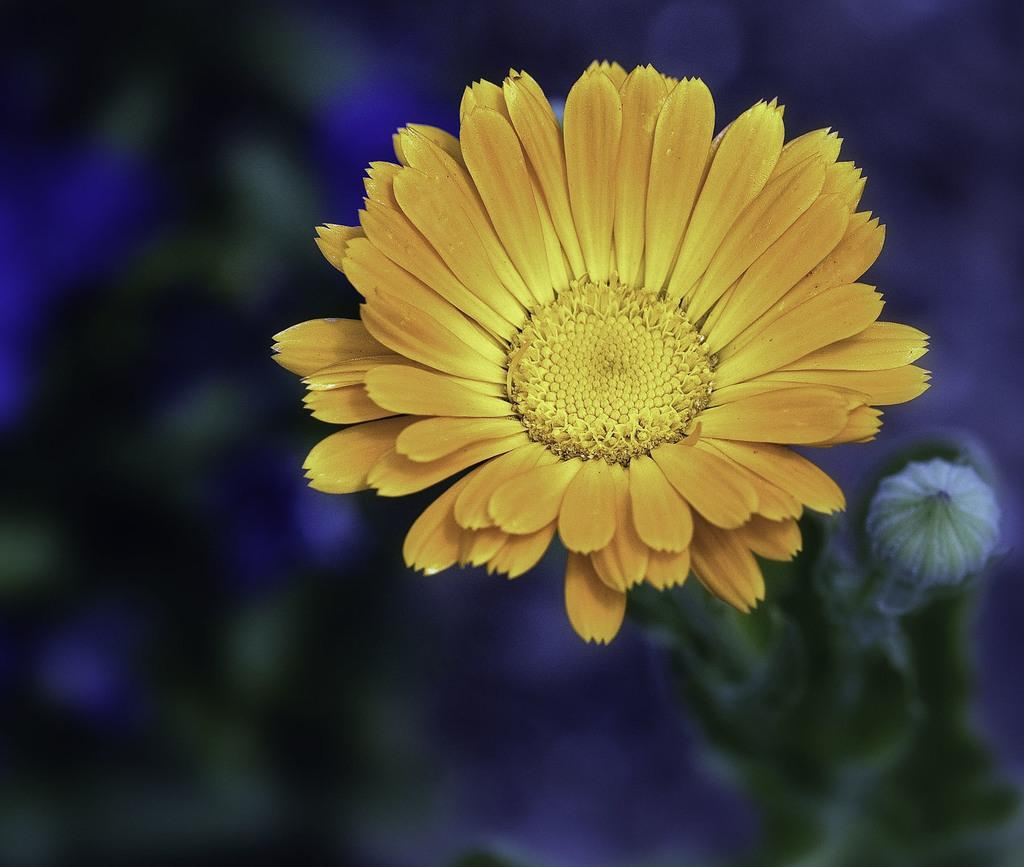What is the main subject of the image? There is a plant in the image. What color is the flower on the plant? The plant has a yellow flower. Can you describe the background of the image? The background of the image is blurred. What type of sleet can be seen falling in the image? There is no sleet present in the image; it is a plant with a yellow flower, and the background is blurred. How many cars are visible in the image? There are no cars present in the image. 